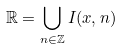<formula> <loc_0><loc_0><loc_500><loc_500>\mathbb { R } = \bigcup _ { n \in \mathbb { Z } } I ( x , n )</formula> 